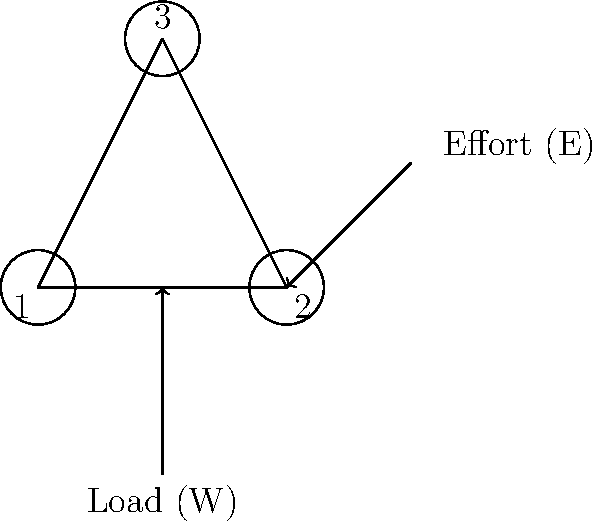As a music teacher preparing for a family event, you've been tasked with setting up a pulley system to hang decorations. The system consists of three pulleys as shown in the diagram. If the load (W) is 300 N, what effort (E) is required to lift the load, assuming the pulleys are ideal (frictionless)? Express your answer in Newtons. To solve this problem, we'll follow these steps:

1) First, we need to determine the mechanical advantage (MA) of the pulley system. The MA is the ratio of the load to the effort: $MA = \frac{W}{E}$

2) In an ideal pulley system, the MA is equal to the number of supporting ropes. To count the supporting ropes:
   - Look at the movable pulleys (pulleys that move with the load)
   - Count the number of rope sections supporting these pulleys

3) In this system:
   - Pulley 1 is fixed
   - Pulleys 2 and 3 are movable
   - There are 3 sections of rope supporting the movable pulleys

4) Therefore, the mechanical advantage is 3: $MA = 3$

5) Now we can use the formula: $MA = \frac{W}{E}$

6) Substituting the known values:
   $3 = \frac{300 N}{E}$

7) Solving for E:
   $E = \frac{300 N}{3} = 100 N$

Thus, an effort of 100 N is required to lift the 300 N load.
Answer: 100 N 